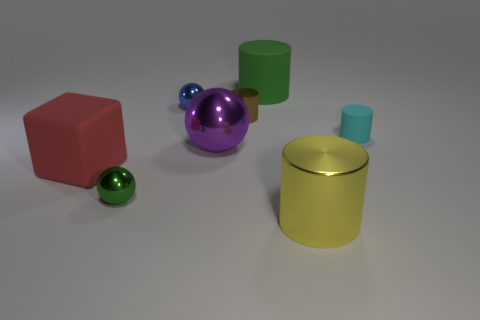Do the ball behind the purple thing and the yellow metal object have the same size?
Your response must be concise. No. Are there any objects of the same color as the large matte cylinder?
Keep it short and to the point. Yes. There is a matte object that is to the right of the yellow metallic cylinder; are there any tiny brown shiny objects in front of it?
Offer a very short reply. No. Is there a red object made of the same material as the large green cylinder?
Your answer should be very brief. Yes. The large cylinder that is behind the large metallic thing in front of the block is made of what material?
Your answer should be compact. Rubber. There is a big thing that is in front of the purple object and behind the large yellow cylinder; what is its material?
Your response must be concise. Rubber. Is the number of big yellow metallic things behind the brown cylinder the same as the number of blue matte spheres?
Your answer should be very brief. Yes. What number of other tiny metallic things have the same shape as the red object?
Offer a terse response. 0. There is a rubber cylinder to the left of the small cylinder that is in front of the metallic cylinder behind the rubber cube; how big is it?
Your answer should be compact. Large. Does the big cylinder in front of the small brown metal object have the same material as the purple thing?
Offer a very short reply. Yes. 